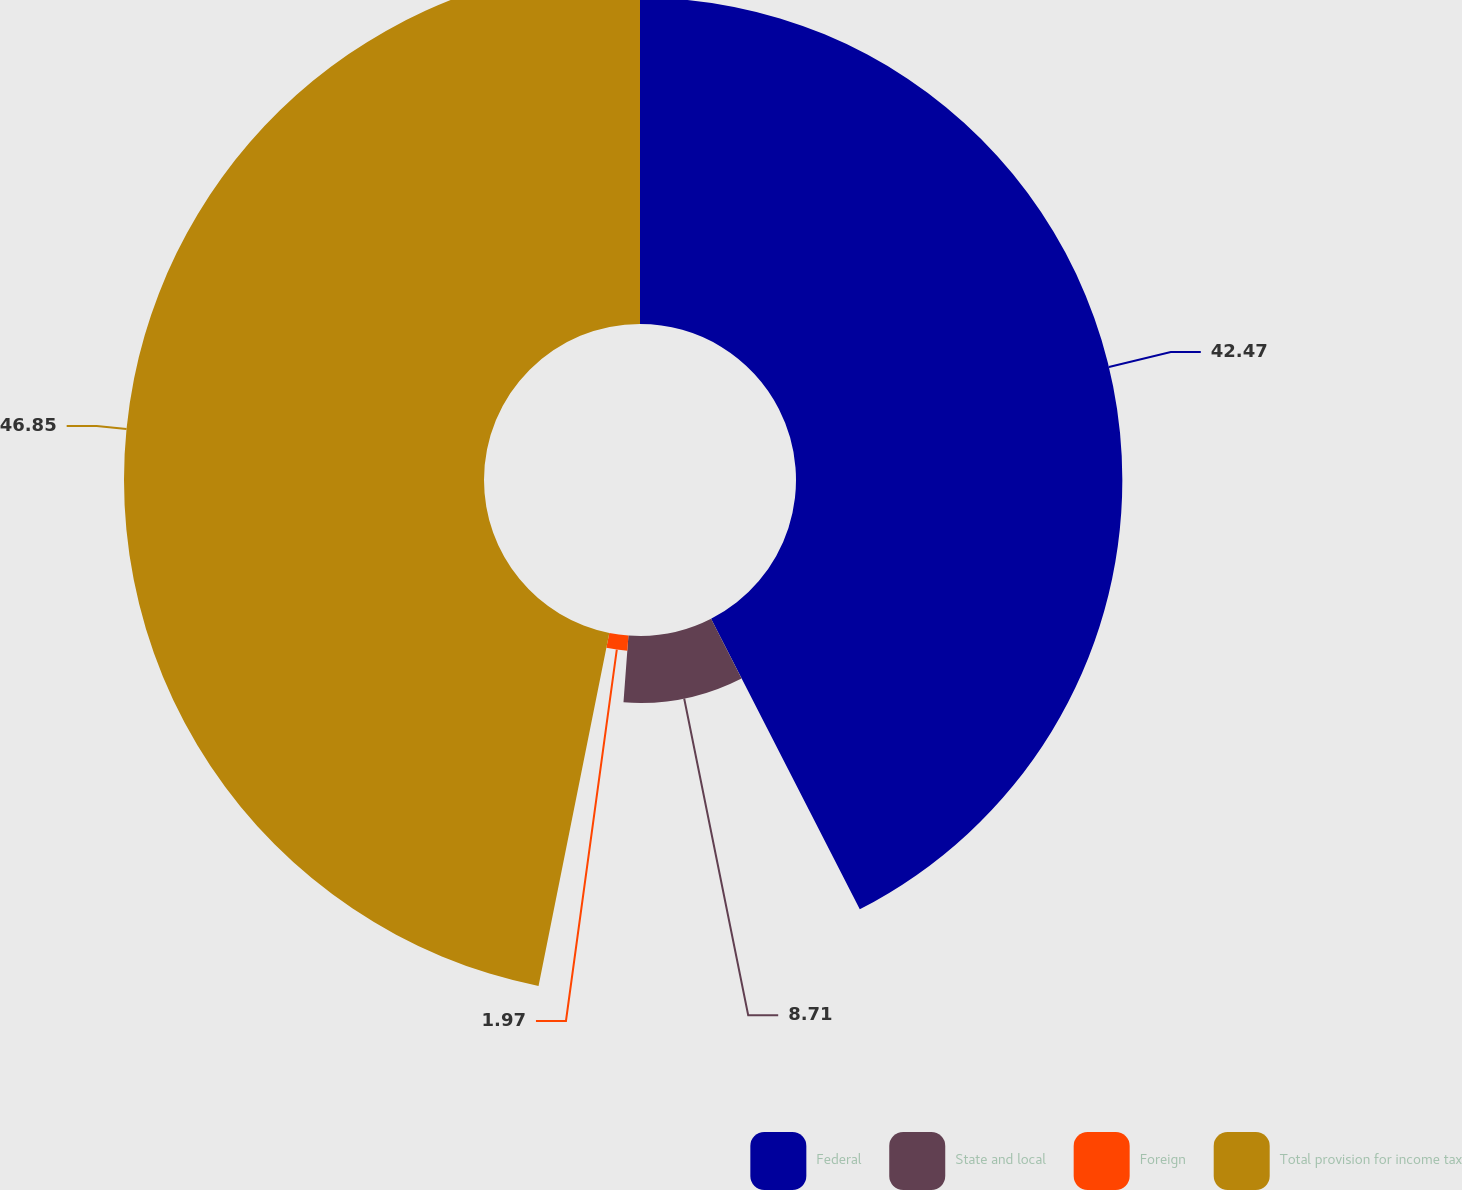<chart> <loc_0><loc_0><loc_500><loc_500><pie_chart><fcel>Federal<fcel>State and local<fcel>Foreign<fcel>Total provision for income tax<nl><fcel>42.47%<fcel>8.71%<fcel>1.97%<fcel>46.85%<nl></chart> 